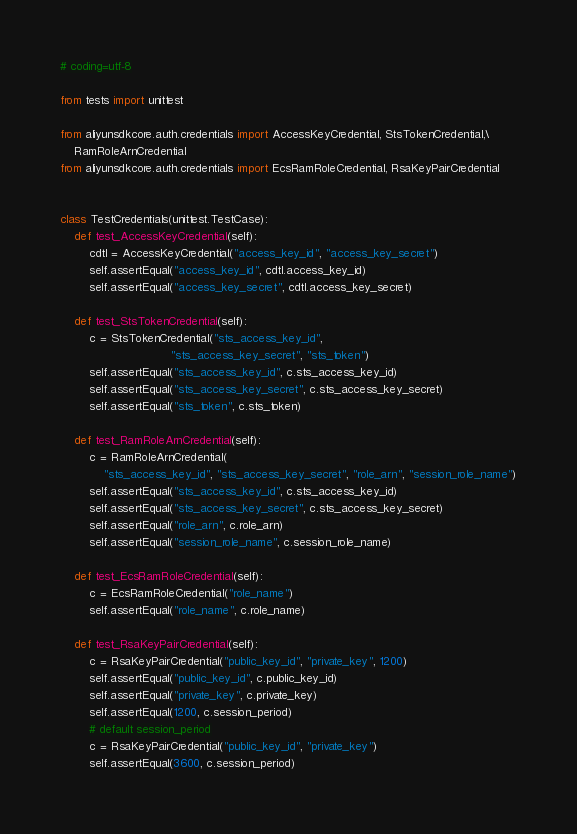Convert code to text. <code><loc_0><loc_0><loc_500><loc_500><_Python_># coding=utf-8

from tests import unittest

from aliyunsdkcore.auth.credentials import AccessKeyCredential, StsTokenCredential,\
    RamRoleArnCredential
from aliyunsdkcore.auth.credentials import EcsRamRoleCredential, RsaKeyPairCredential


class TestCredentials(unittest.TestCase):
    def test_AccessKeyCredential(self):
        cdtl = AccessKeyCredential("access_key_id", "access_key_secret")
        self.assertEqual("access_key_id", cdtl.access_key_id)
        self.assertEqual("access_key_secret", cdtl.access_key_secret)

    def test_StsTokenCredential(self):
        c = StsTokenCredential("sts_access_key_id",
                               "sts_access_key_secret", "sts_token")
        self.assertEqual("sts_access_key_id", c.sts_access_key_id)
        self.assertEqual("sts_access_key_secret", c.sts_access_key_secret)
        self.assertEqual("sts_token", c.sts_token)

    def test_RamRoleArnCredential(self):
        c = RamRoleArnCredential(
            "sts_access_key_id", "sts_access_key_secret", "role_arn", "session_role_name")
        self.assertEqual("sts_access_key_id", c.sts_access_key_id)
        self.assertEqual("sts_access_key_secret", c.sts_access_key_secret)
        self.assertEqual("role_arn", c.role_arn)
        self.assertEqual("session_role_name", c.session_role_name)

    def test_EcsRamRoleCredential(self):
        c = EcsRamRoleCredential("role_name")
        self.assertEqual("role_name", c.role_name)

    def test_RsaKeyPairCredential(self):
        c = RsaKeyPairCredential("public_key_id", "private_key", 1200)
        self.assertEqual("public_key_id", c.public_key_id)
        self.assertEqual("private_key", c.private_key)
        self.assertEqual(1200, c.session_period)
        # default session_period
        c = RsaKeyPairCredential("public_key_id", "private_key")
        self.assertEqual(3600, c.session_period)
</code> 